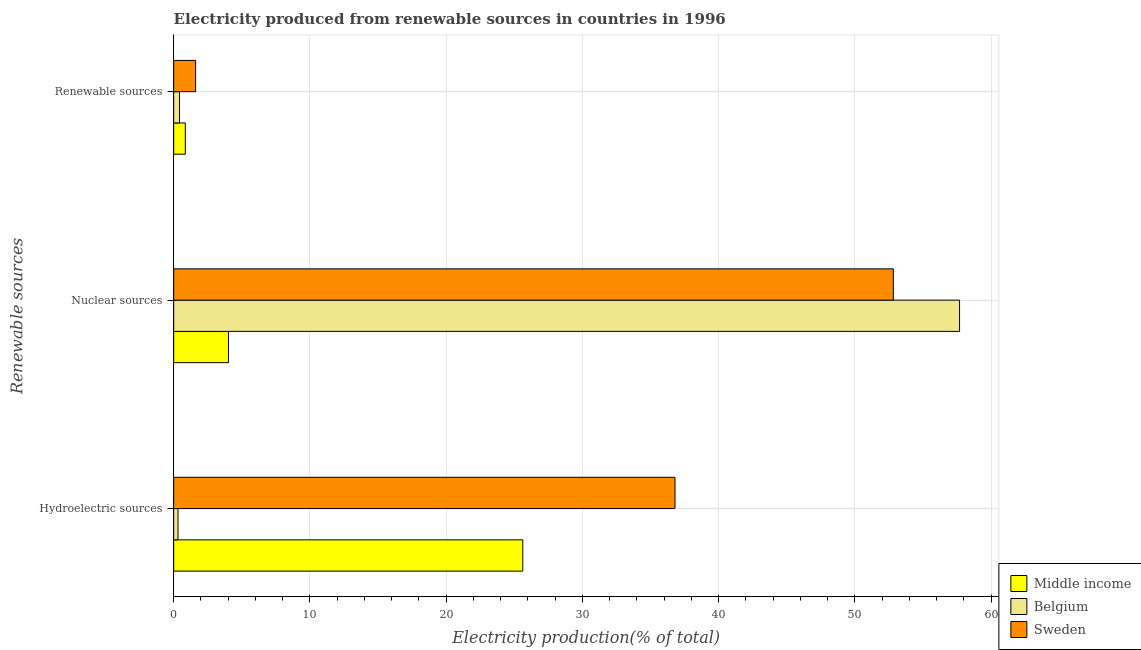How many groups of bars are there?
Give a very brief answer. 3. Are the number of bars per tick equal to the number of legend labels?
Make the answer very short. Yes. How many bars are there on the 2nd tick from the top?
Provide a short and direct response. 3. How many bars are there on the 1st tick from the bottom?
Give a very brief answer. 3. What is the label of the 2nd group of bars from the top?
Provide a succinct answer. Nuclear sources. What is the percentage of electricity produced by nuclear sources in Belgium?
Keep it short and to the point. 57.68. Across all countries, what is the maximum percentage of electricity produced by hydroelectric sources?
Ensure brevity in your answer.  36.79. Across all countries, what is the minimum percentage of electricity produced by hydroelectric sources?
Ensure brevity in your answer.  0.32. In which country was the percentage of electricity produced by renewable sources minimum?
Provide a succinct answer. Belgium. What is the total percentage of electricity produced by hydroelectric sources in the graph?
Your answer should be compact. 62.73. What is the difference between the percentage of electricity produced by hydroelectric sources in Sweden and that in Belgium?
Your answer should be very brief. 36.47. What is the difference between the percentage of electricity produced by hydroelectric sources in Middle income and the percentage of electricity produced by renewable sources in Sweden?
Your response must be concise. 24.01. What is the average percentage of electricity produced by renewable sources per country?
Your response must be concise. 0.96. What is the difference between the percentage of electricity produced by nuclear sources and percentage of electricity produced by renewable sources in Sweden?
Provide a succinct answer. 51.21. In how many countries, is the percentage of electricity produced by nuclear sources greater than 46 %?
Provide a succinct answer. 2. What is the ratio of the percentage of electricity produced by renewable sources in Sweden to that in Belgium?
Your response must be concise. 3.76. What is the difference between the highest and the second highest percentage of electricity produced by hydroelectric sources?
Give a very brief answer. 11.17. What is the difference between the highest and the lowest percentage of electricity produced by hydroelectric sources?
Provide a short and direct response. 36.47. In how many countries, is the percentage of electricity produced by hydroelectric sources greater than the average percentage of electricity produced by hydroelectric sources taken over all countries?
Your answer should be very brief. 2. What does the 3rd bar from the top in Nuclear sources represents?
Your answer should be compact. Middle income. Are all the bars in the graph horizontal?
Provide a short and direct response. Yes. Are the values on the major ticks of X-axis written in scientific E-notation?
Give a very brief answer. No. What is the title of the graph?
Your answer should be compact. Electricity produced from renewable sources in countries in 1996. What is the label or title of the X-axis?
Make the answer very short. Electricity production(% of total). What is the label or title of the Y-axis?
Ensure brevity in your answer.  Renewable sources. What is the Electricity production(% of total) of Middle income in Hydroelectric sources?
Give a very brief answer. 25.62. What is the Electricity production(% of total) in Belgium in Hydroelectric sources?
Provide a short and direct response. 0.32. What is the Electricity production(% of total) in Sweden in Hydroelectric sources?
Keep it short and to the point. 36.79. What is the Electricity production(% of total) in Middle income in Nuclear sources?
Your answer should be very brief. 4.02. What is the Electricity production(% of total) of Belgium in Nuclear sources?
Your answer should be very brief. 57.68. What is the Electricity production(% of total) in Sweden in Nuclear sources?
Ensure brevity in your answer.  52.82. What is the Electricity production(% of total) of Middle income in Renewable sources?
Provide a short and direct response. 0.86. What is the Electricity production(% of total) of Belgium in Renewable sources?
Provide a succinct answer. 0.43. What is the Electricity production(% of total) in Sweden in Renewable sources?
Keep it short and to the point. 1.61. Across all Renewable sources, what is the maximum Electricity production(% of total) in Middle income?
Give a very brief answer. 25.62. Across all Renewable sources, what is the maximum Electricity production(% of total) of Belgium?
Your response must be concise. 57.68. Across all Renewable sources, what is the maximum Electricity production(% of total) of Sweden?
Provide a succinct answer. 52.82. Across all Renewable sources, what is the minimum Electricity production(% of total) in Middle income?
Offer a very short reply. 0.86. Across all Renewable sources, what is the minimum Electricity production(% of total) of Belgium?
Your answer should be compact. 0.32. Across all Renewable sources, what is the minimum Electricity production(% of total) in Sweden?
Provide a succinct answer. 1.61. What is the total Electricity production(% of total) in Middle income in the graph?
Give a very brief answer. 30.5. What is the total Electricity production(% of total) of Belgium in the graph?
Your answer should be compact. 58.42. What is the total Electricity production(% of total) of Sweden in the graph?
Keep it short and to the point. 91.22. What is the difference between the Electricity production(% of total) of Middle income in Hydroelectric sources and that in Nuclear sources?
Offer a terse response. 21.6. What is the difference between the Electricity production(% of total) in Belgium in Hydroelectric sources and that in Nuclear sources?
Make the answer very short. -57.36. What is the difference between the Electricity production(% of total) in Sweden in Hydroelectric sources and that in Nuclear sources?
Provide a succinct answer. -16.02. What is the difference between the Electricity production(% of total) of Middle income in Hydroelectric sources and that in Renewable sources?
Your response must be concise. 24.77. What is the difference between the Electricity production(% of total) of Belgium in Hydroelectric sources and that in Renewable sources?
Offer a very short reply. -0.11. What is the difference between the Electricity production(% of total) of Sweden in Hydroelectric sources and that in Renewable sources?
Provide a succinct answer. 35.18. What is the difference between the Electricity production(% of total) in Middle income in Nuclear sources and that in Renewable sources?
Your response must be concise. 3.17. What is the difference between the Electricity production(% of total) of Belgium in Nuclear sources and that in Renewable sources?
Offer a terse response. 57.25. What is the difference between the Electricity production(% of total) of Sweden in Nuclear sources and that in Renewable sources?
Your response must be concise. 51.21. What is the difference between the Electricity production(% of total) of Middle income in Hydroelectric sources and the Electricity production(% of total) of Belgium in Nuclear sources?
Your answer should be compact. -32.05. What is the difference between the Electricity production(% of total) of Middle income in Hydroelectric sources and the Electricity production(% of total) of Sweden in Nuclear sources?
Give a very brief answer. -27.19. What is the difference between the Electricity production(% of total) in Belgium in Hydroelectric sources and the Electricity production(% of total) in Sweden in Nuclear sources?
Offer a terse response. -52.5. What is the difference between the Electricity production(% of total) of Middle income in Hydroelectric sources and the Electricity production(% of total) of Belgium in Renewable sources?
Offer a very short reply. 25.19. What is the difference between the Electricity production(% of total) in Middle income in Hydroelectric sources and the Electricity production(% of total) in Sweden in Renewable sources?
Give a very brief answer. 24.01. What is the difference between the Electricity production(% of total) in Belgium in Hydroelectric sources and the Electricity production(% of total) in Sweden in Renewable sources?
Offer a terse response. -1.29. What is the difference between the Electricity production(% of total) of Middle income in Nuclear sources and the Electricity production(% of total) of Belgium in Renewable sources?
Provide a short and direct response. 3.59. What is the difference between the Electricity production(% of total) of Middle income in Nuclear sources and the Electricity production(% of total) of Sweden in Renewable sources?
Keep it short and to the point. 2.41. What is the difference between the Electricity production(% of total) in Belgium in Nuclear sources and the Electricity production(% of total) in Sweden in Renewable sources?
Provide a short and direct response. 56.07. What is the average Electricity production(% of total) in Middle income per Renewable sources?
Your answer should be very brief. 10.17. What is the average Electricity production(% of total) in Belgium per Renewable sources?
Your answer should be compact. 19.47. What is the average Electricity production(% of total) of Sweden per Renewable sources?
Your answer should be compact. 30.41. What is the difference between the Electricity production(% of total) of Middle income and Electricity production(% of total) of Belgium in Hydroelectric sources?
Provide a short and direct response. 25.3. What is the difference between the Electricity production(% of total) in Middle income and Electricity production(% of total) in Sweden in Hydroelectric sources?
Your answer should be very brief. -11.17. What is the difference between the Electricity production(% of total) in Belgium and Electricity production(% of total) in Sweden in Hydroelectric sources?
Your answer should be compact. -36.47. What is the difference between the Electricity production(% of total) of Middle income and Electricity production(% of total) of Belgium in Nuclear sources?
Provide a short and direct response. -53.65. What is the difference between the Electricity production(% of total) in Middle income and Electricity production(% of total) in Sweden in Nuclear sources?
Your answer should be compact. -48.8. What is the difference between the Electricity production(% of total) of Belgium and Electricity production(% of total) of Sweden in Nuclear sources?
Keep it short and to the point. 4.86. What is the difference between the Electricity production(% of total) in Middle income and Electricity production(% of total) in Belgium in Renewable sources?
Keep it short and to the point. 0.43. What is the difference between the Electricity production(% of total) in Middle income and Electricity production(% of total) in Sweden in Renewable sources?
Ensure brevity in your answer.  -0.75. What is the difference between the Electricity production(% of total) in Belgium and Electricity production(% of total) in Sweden in Renewable sources?
Your answer should be compact. -1.18. What is the ratio of the Electricity production(% of total) in Middle income in Hydroelectric sources to that in Nuclear sources?
Offer a very short reply. 6.37. What is the ratio of the Electricity production(% of total) in Belgium in Hydroelectric sources to that in Nuclear sources?
Your answer should be compact. 0.01. What is the ratio of the Electricity production(% of total) in Sweden in Hydroelectric sources to that in Nuclear sources?
Give a very brief answer. 0.7. What is the ratio of the Electricity production(% of total) of Middle income in Hydroelectric sources to that in Renewable sources?
Your answer should be compact. 29.95. What is the ratio of the Electricity production(% of total) of Belgium in Hydroelectric sources to that in Renewable sources?
Provide a short and direct response. 0.74. What is the ratio of the Electricity production(% of total) in Sweden in Hydroelectric sources to that in Renewable sources?
Ensure brevity in your answer.  22.86. What is the ratio of the Electricity production(% of total) of Middle income in Nuclear sources to that in Renewable sources?
Keep it short and to the point. 4.7. What is the ratio of the Electricity production(% of total) of Belgium in Nuclear sources to that in Renewable sources?
Offer a very short reply. 134.58. What is the ratio of the Electricity production(% of total) in Sweden in Nuclear sources to that in Renewable sources?
Provide a short and direct response. 32.82. What is the difference between the highest and the second highest Electricity production(% of total) in Middle income?
Your answer should be very brief. 21.6. What is the difference between the highest and the second highest Electricity production(% of total) in Belgium?
Offer a terse response. 57.25. What is the difference between the highest and the second highest Electricity production(% of total) of Sweden?
Your answer should be compact. 16.02. What is the difference between the highest and the lowest Electricity production(% of total) in Middle income?
Give a very brief answer. 24.77. What is the difference between the highest and the lowest Electricity production(% of total) of Belgium?
Ensure brevity in your answer.  57.36. What is the difference between the highest and the lowest Electricity production(% of total) in Sweden?
Keep it short and to the point. 51.21. 